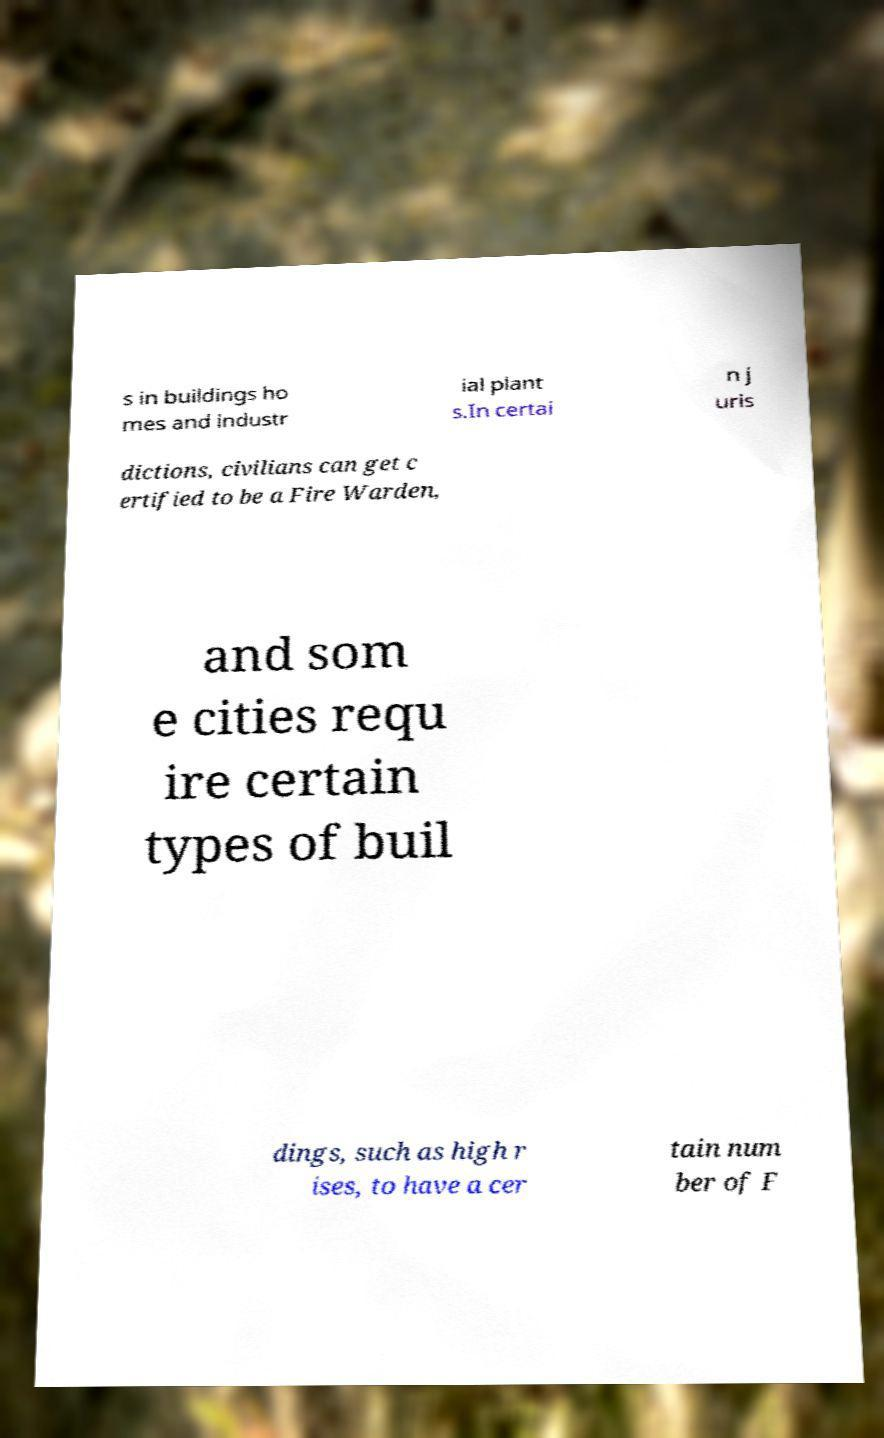There's text embedded in this image that I need extracted. Can you transcribe it verbatim? s in buildings ho mes and industr ial plant s.In certai n j uris dictions, civilians can get c ertified to be a Fire Warden, and som e cities requ ire certain types of buil dings, such as high r ises, to have a cer tain num ber of F 